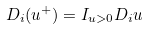Convert formula to latex. <formula><loc_0><loc_0><loc_500><loc_500>D _ { i } ( u ^ { + } ) = I _ { u > 0 } D _ { i } u</formula> 